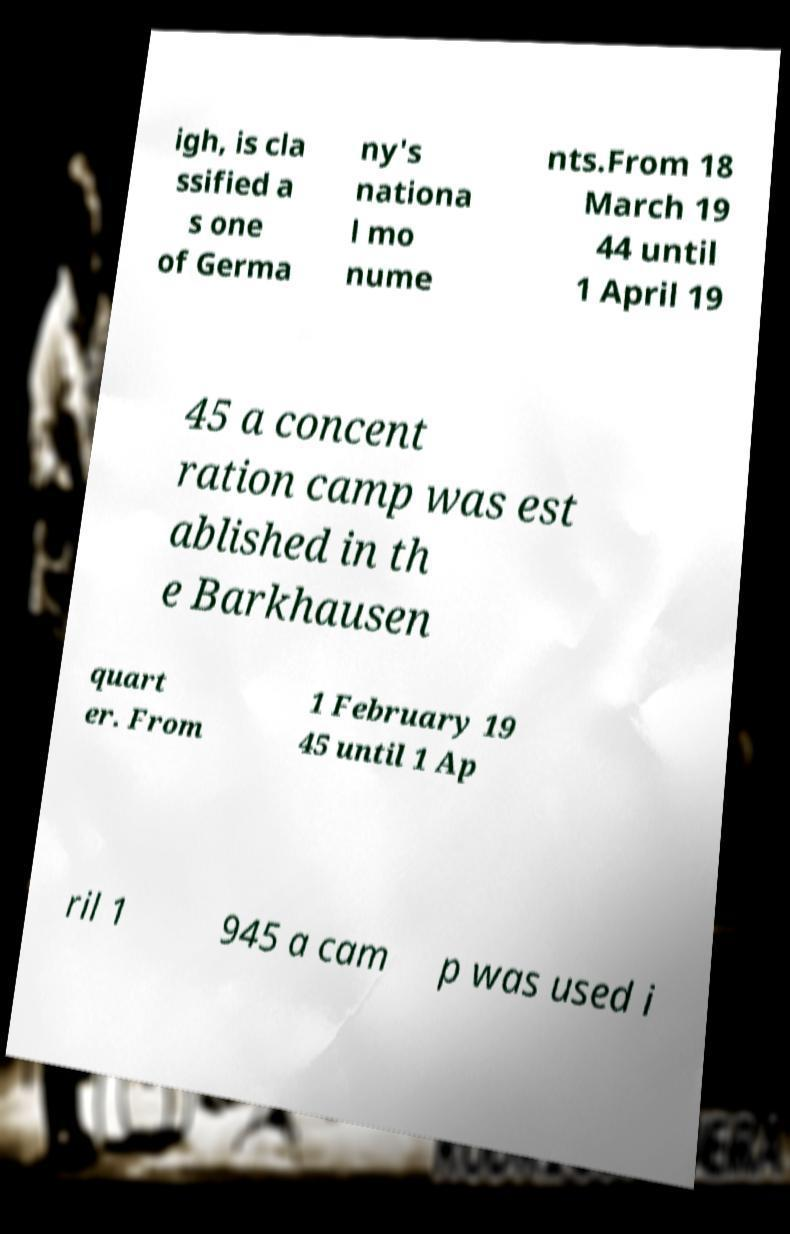Can you accurately transcribe the text from the provided image for me? igh, is cla ssified a s one of Germa ny's nationa l mo nume nts.From 18 March 19 44 until 1 April 19 45 a concent ration camp was est ablished in th e Barkhausen quart er. From 1 February 19 45 until 1 Ap ril 1 945 a cam p was used i 